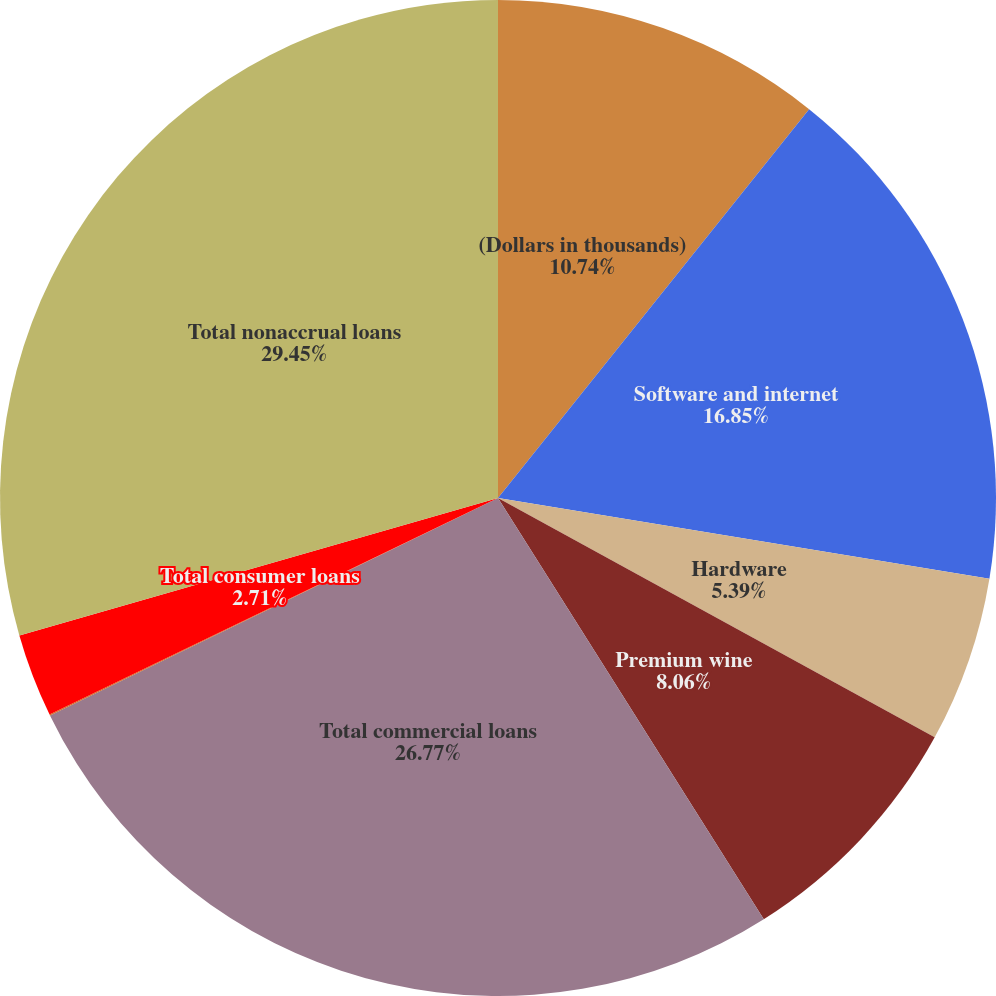<chart> <loc_0><loc_0><loc_500><loc_500><pie_chart><fcel>(Dollars in thousands)<fcel>Software and internet<fcel>Hardware<fcel>Premium wine<fcel>Total commercial loans<fcel>Real estate secured loans<fcel>Total consumer loans<fcel>Total nonaccrual loans<nl><fcel>10.74%<fcel>16.85%<fcel>5.39%<fcel>8.06%<fcel>26.77%<fcel>0.03%<fcel>2.71%<fcel>29.45%<nl></chart> 